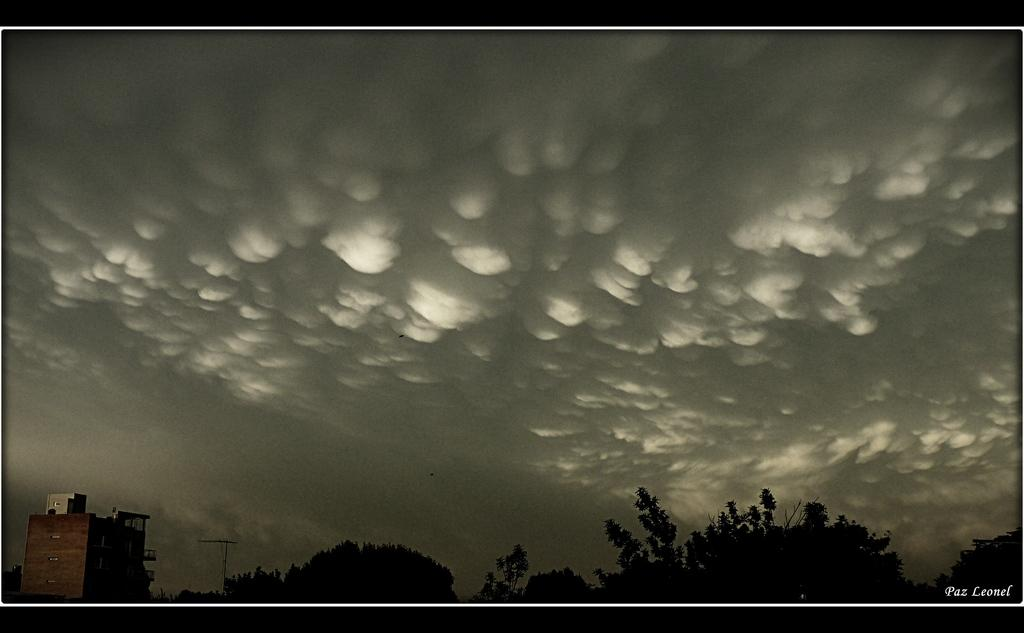What type of natural elements can be seen in the image? There are many trees in the image. What structure is located on the left side of the image? There is a building on the left side of the image. What can be seen in the back of the image? There are clouds and the sky visible in the back of the image. What type of substance is being discussed by the committee in the image? There is no committee or discussion of any substance present in the image. Can you tell me how many kitties are playing among the trees in the image? There are no kitties present in the image; it features trees, a building, clouds, and the sky. 